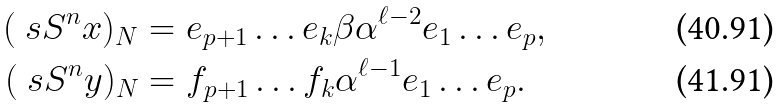Convert formula to latex. <formula><loc_0><loc_0><loc_500><loc_500>( \ s S ^ { n } { x } ) _ { N } & = e _ { p + 1 } \dots e _ { k } \beta \alpha ^ { \ell - 2 } e _ { 1 } \dots e _ { p } , \\ ( \ s S ^ { n } { y } ) _ { N } & = f _ { p + 1 } \dots f _ { k } \alpha ^ { \ell - 1 } e _ { 1 } \dots e _ { p } .</formula> 